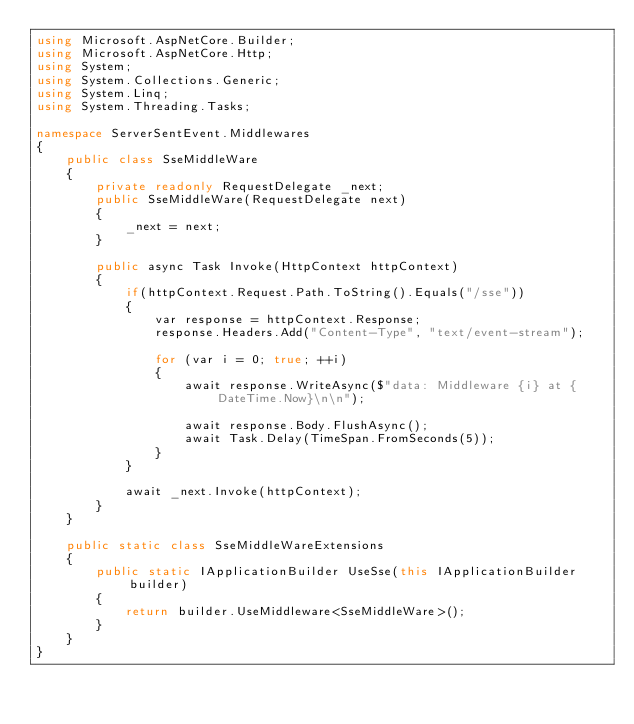Convert code to text. <code><loc_0><loc_0><loc_500><loc_500><_C#_>using Microsoft.AspNetCore.Builder;
using Microsoft.AspNetCore.Http;
using System;
using System.Collections.Generic;
using System.Linq;
using System.Threading.Tasks;

namespace ServerSentEvent.Middlewares
{
    public class SseMiddleWare
    {
        private readonly RequestDelegate _next;
        public SseMiddleWare(RequestDelegate next)
        {
            _next = next;
        }

        public async Task Invoke(HttpContext httpContext)
        {
            if(httpContext.Request.Path.ToString().Equals("/sse"))
            {
                var response = httpContext.Response;
                response.Headers.Add("Content-Type", "text/event-stream");

                for (var i = 0; true; ++i)
                {
                    await response.WriteAsync($"data: Middleware {i} at {DateTime.Now}\n\n");

                    await response.Body.FlushAsync();
                    await Task.Delay(TimeSpan.FromSeconds(5));
                }
            }

            await _next.Invoke(httpContext);
        }
    }

    public static class SseMiddleWareExtensions
    {
        public static IApplicationBuilder UseSse(this IApplicationBuilder builder)
        {
            return builder.UseMiddleware<SseMiddleWare>();
        }
    }
}
</code> 